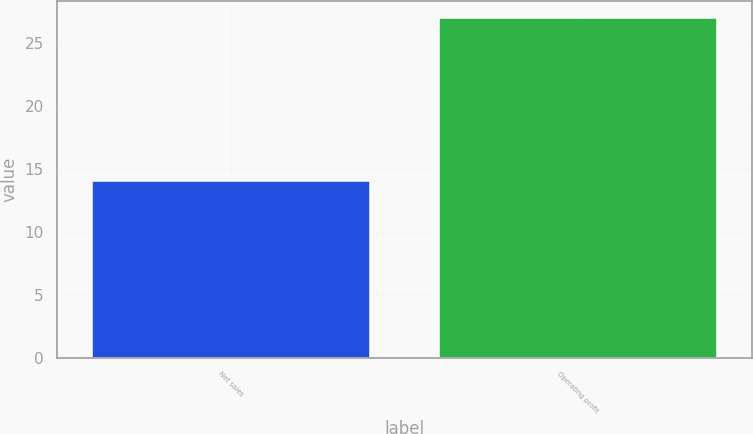<chart> <loc_0><loc_0><loc_500><loc_500><bar_chart><fcel>Net sales<fcel>Operating profit<nl><fcel>14<fcel>27<nl></chart> 